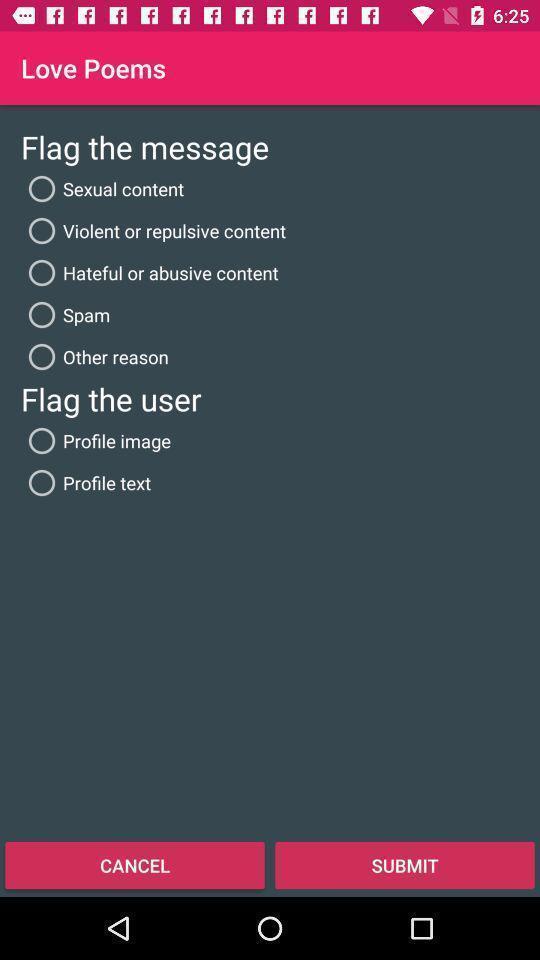Give me a summary of this screen capture. Screen shows love poems list in a chat app. 